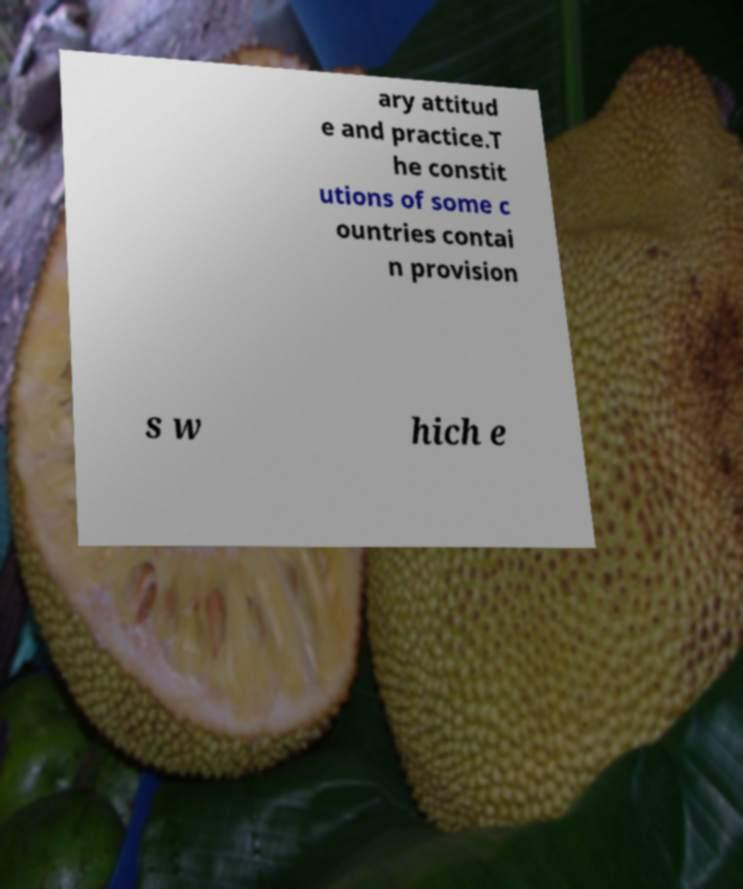Can you read and provide the text displayed in the image?This photo seems to have some interesting text. Can you extract and type it out for me? ary attitud e and practice.T he constit utions of some c ountries contai n provision s w hich e 